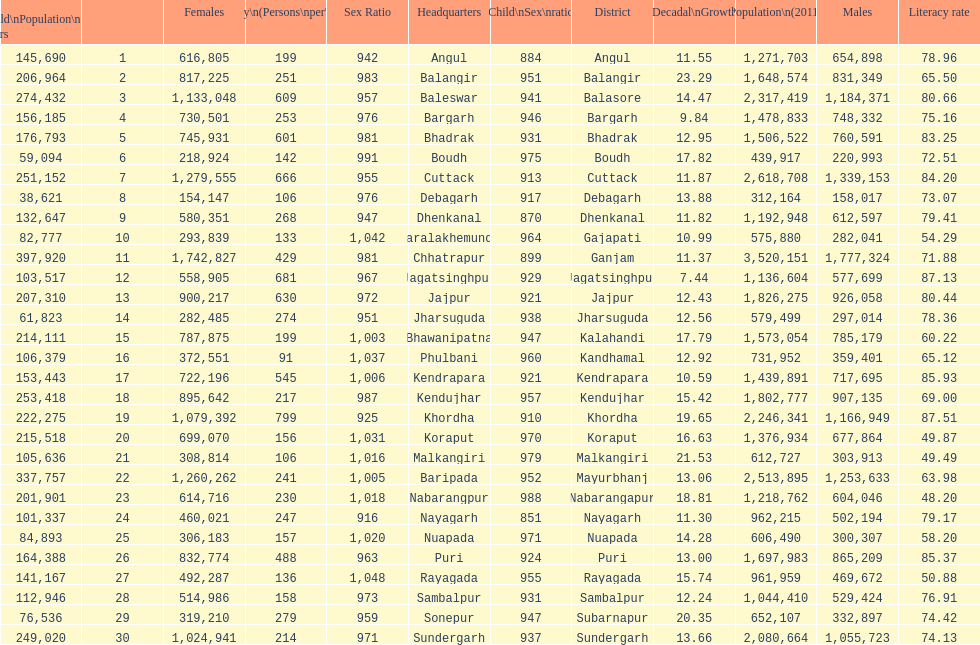What is the number of districts with percentage decadal growth above 15% 10. 